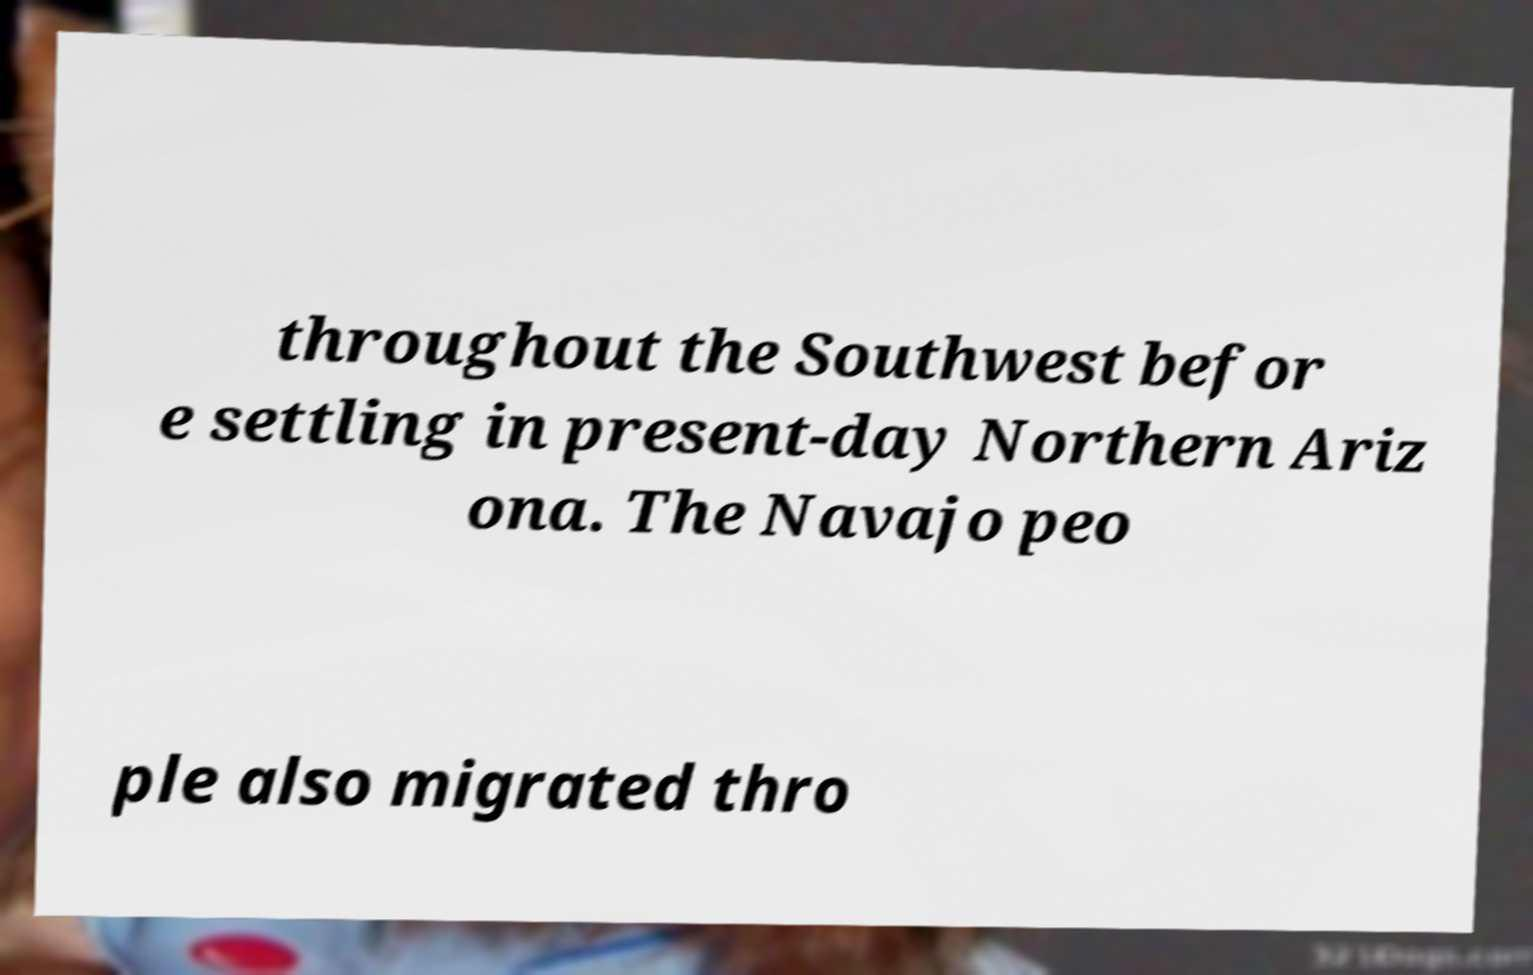Could you assist in decoding the text presented in this image and type it out clearly? throughout the Southwest befor e settling in present-day Northern Ariz ona. The Navajo peo ple also migrated thro 